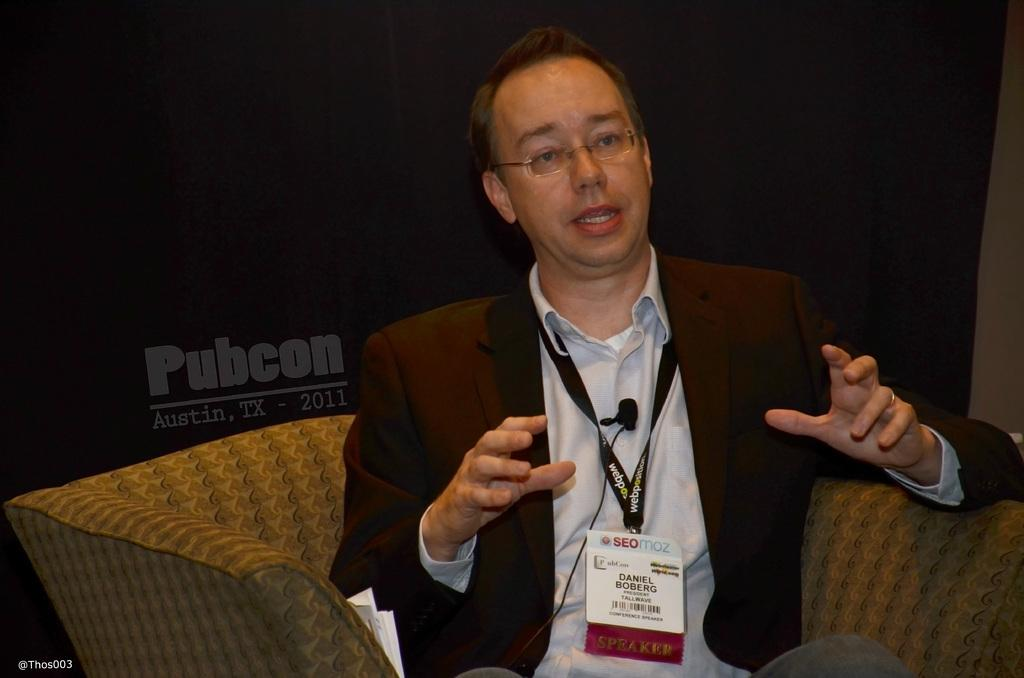What is the man in the image doing? The man is sitting on a sofa in the image. What is the man wearing? The man is wearing a coat. What object is the man holding in the image? The man is holding an ID card. What type of planes is the man drawing with a pencil in the image? There is no pencil or planes present in the image. What type of servant is attending to the man in the image? There is no servant present in the image. 